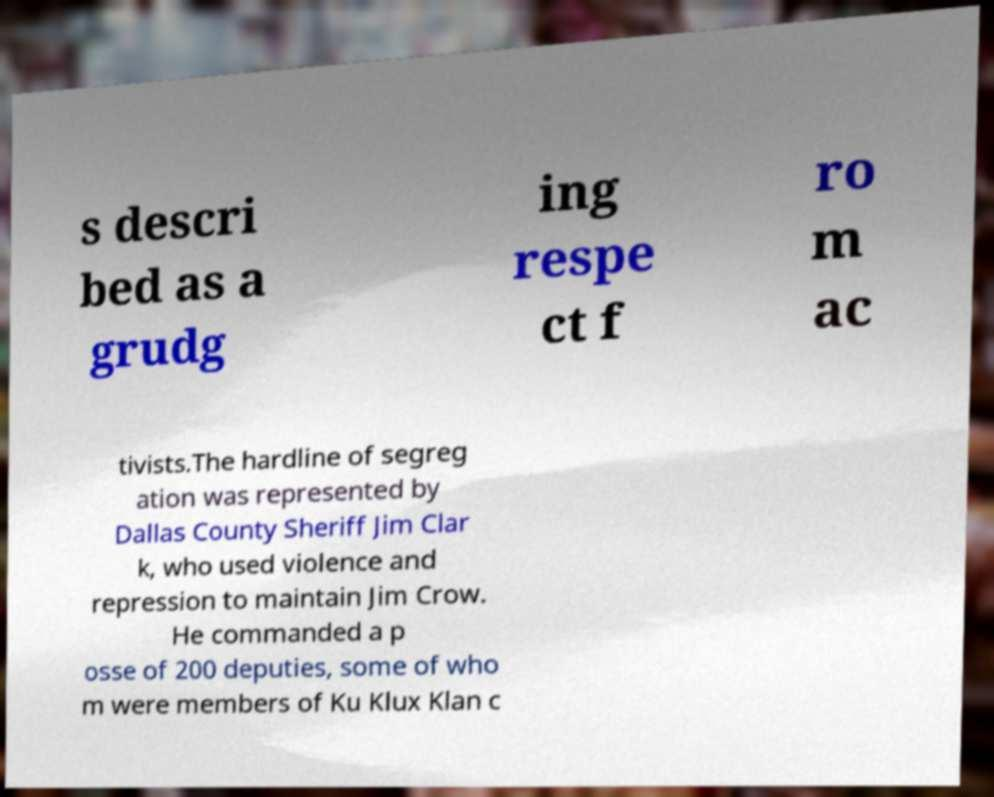Can you accurately transcribe the text from the provided image for me? s descri bed as a grudg ing respe ct f ro m ac tivists.The hardline of segreg ation was represented by Dallas County Sheriff Jim Clar k, who used violence and repression to maintain Jim Crow. He commanded a p osse of 200 deputies, some of who m were members of Ku Klux Klan c 